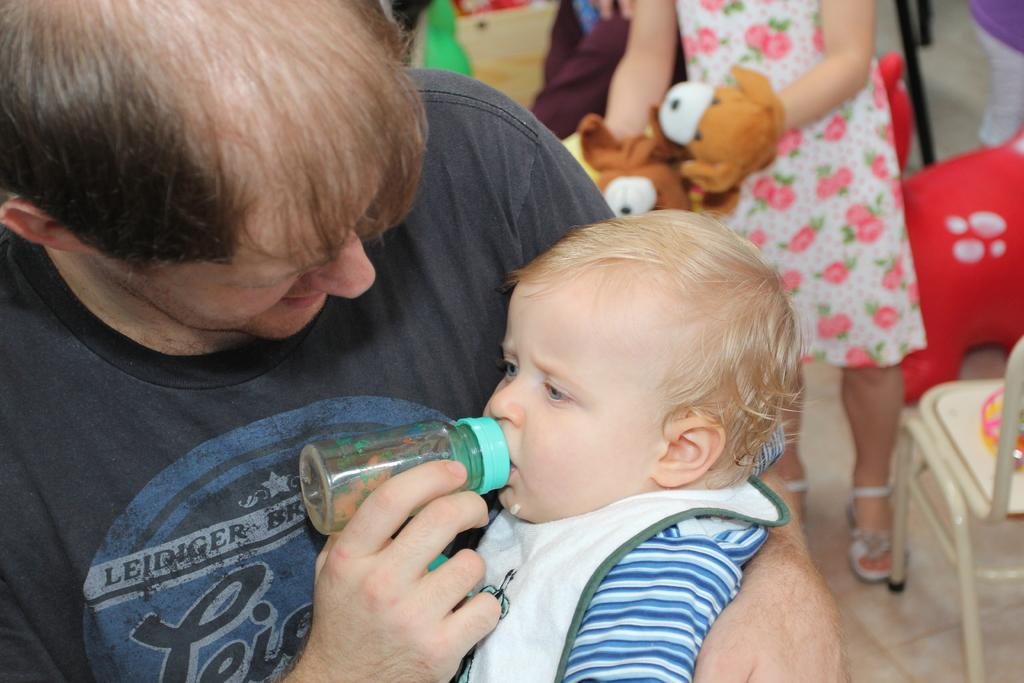What is the person in the image doing? The person is carrying a baby in the image. What is the baby doing while being carried? The baby is drinking through a bottle. Who else is present in the image? There is a girl standing behind the person carrying the baby. What is the girl holding? The girl is holding soft toys. Can you describe the furniture in the image? There is a chair to the right of the girl. Is there a tiger jumping over the crook in the image? No, there is no tiger or crook present in the image. 